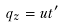<formula> <loc_0><loc_0><loc_500><loc_500>q _ { z } = u t ^ { \prime }</formula> 